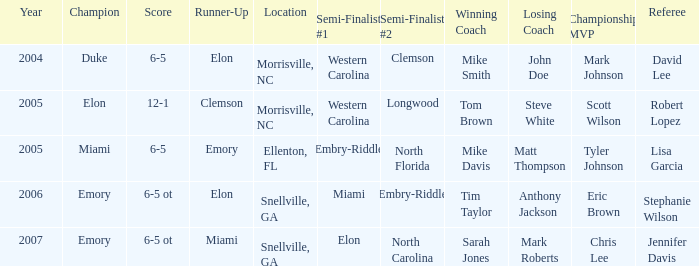How many teams were listed as runner up in 2005 and there the first semi finalist was Western Carolina? 1.0. 